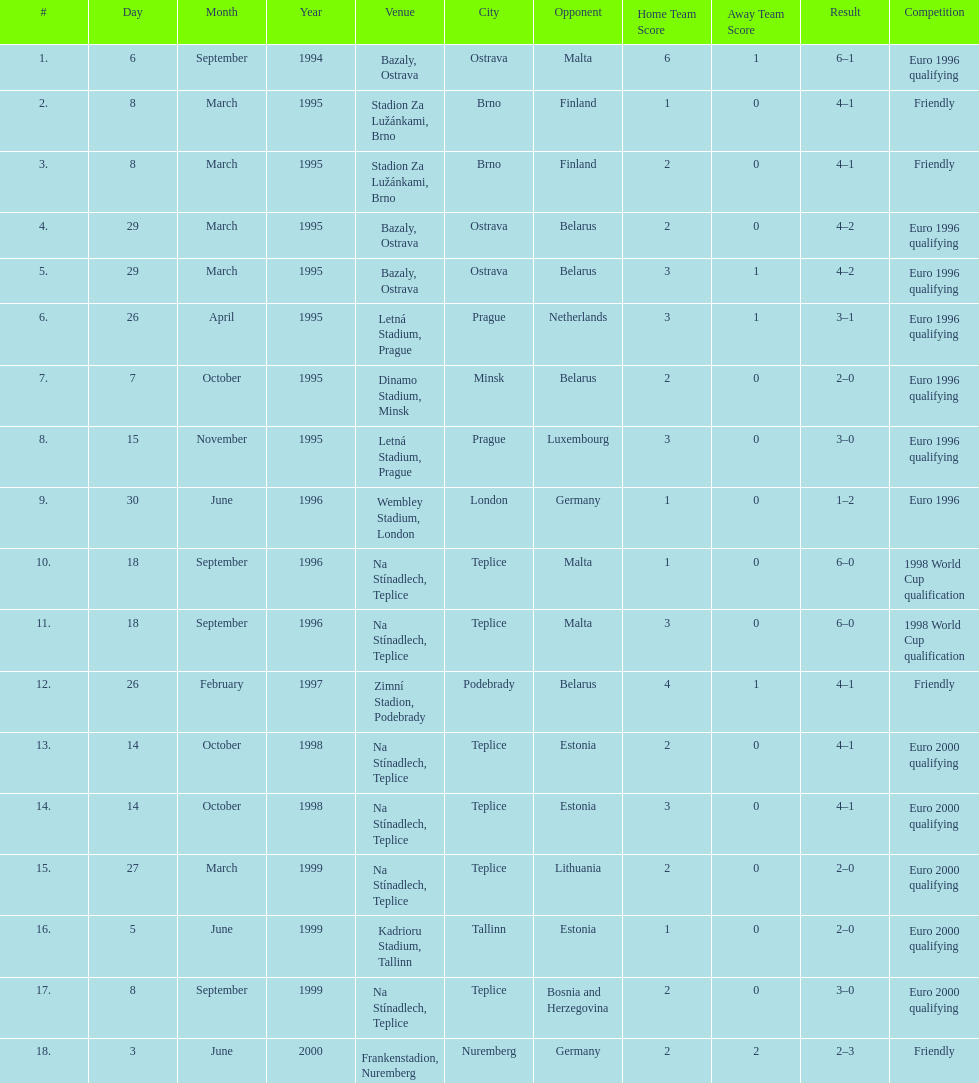List the opponent in which the result was the least out of all the results. Germany. 